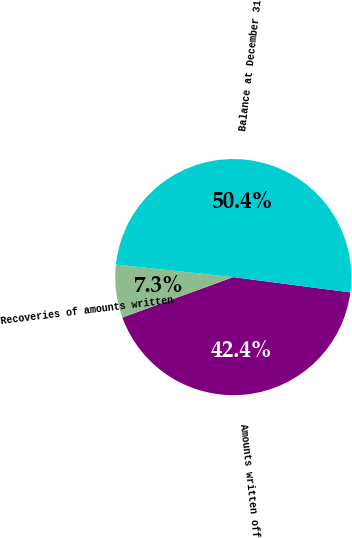Convert chart to OTSL. <chart><loc_0><loc_0><loc_500><loc_500><pie_chart><fcel>Amounts written off<fcel>Recoveries of amounts written<fcel>Balance at December 31<nl><fcel>42.37%<fcel>7.26%<fcel>50.37%<nl></chart> 